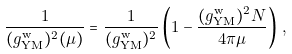Convert formula to latex. <formula><loc_0><loc_0><loc_500><loc_500>\frac { 1 } { ( g _ { \text {YM} } ^ { \text {w} } ) ^ { 2 } ( \mu ) } = \frac { 1 } { ( g _ { \text {YM} } ^ { \text {w} } ) ^ { 2 } } \left ( 1 - \frac { ( g _ { \text {YM} } ^ { \text {w} } ) ^ { 2 } N } { 4 \pi \mu } \right ) \, ,</formula> 